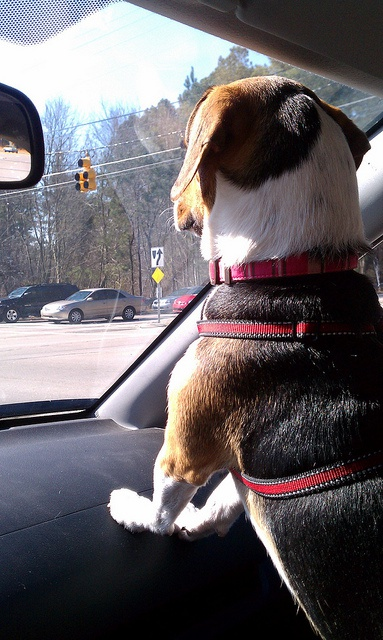Describe the objects in this image and their specific colors. I can see dog in lightblue, black, gray, white, and maroon tones, car in lightblue, gray, white, and darkgray tones, car in lightblue, black, gray, and darkblue tones, car in lightblue, darkgray, lavender, and gray tones, and car in lightblue, lightpink, darkgray, violet, and black tones in this image. 